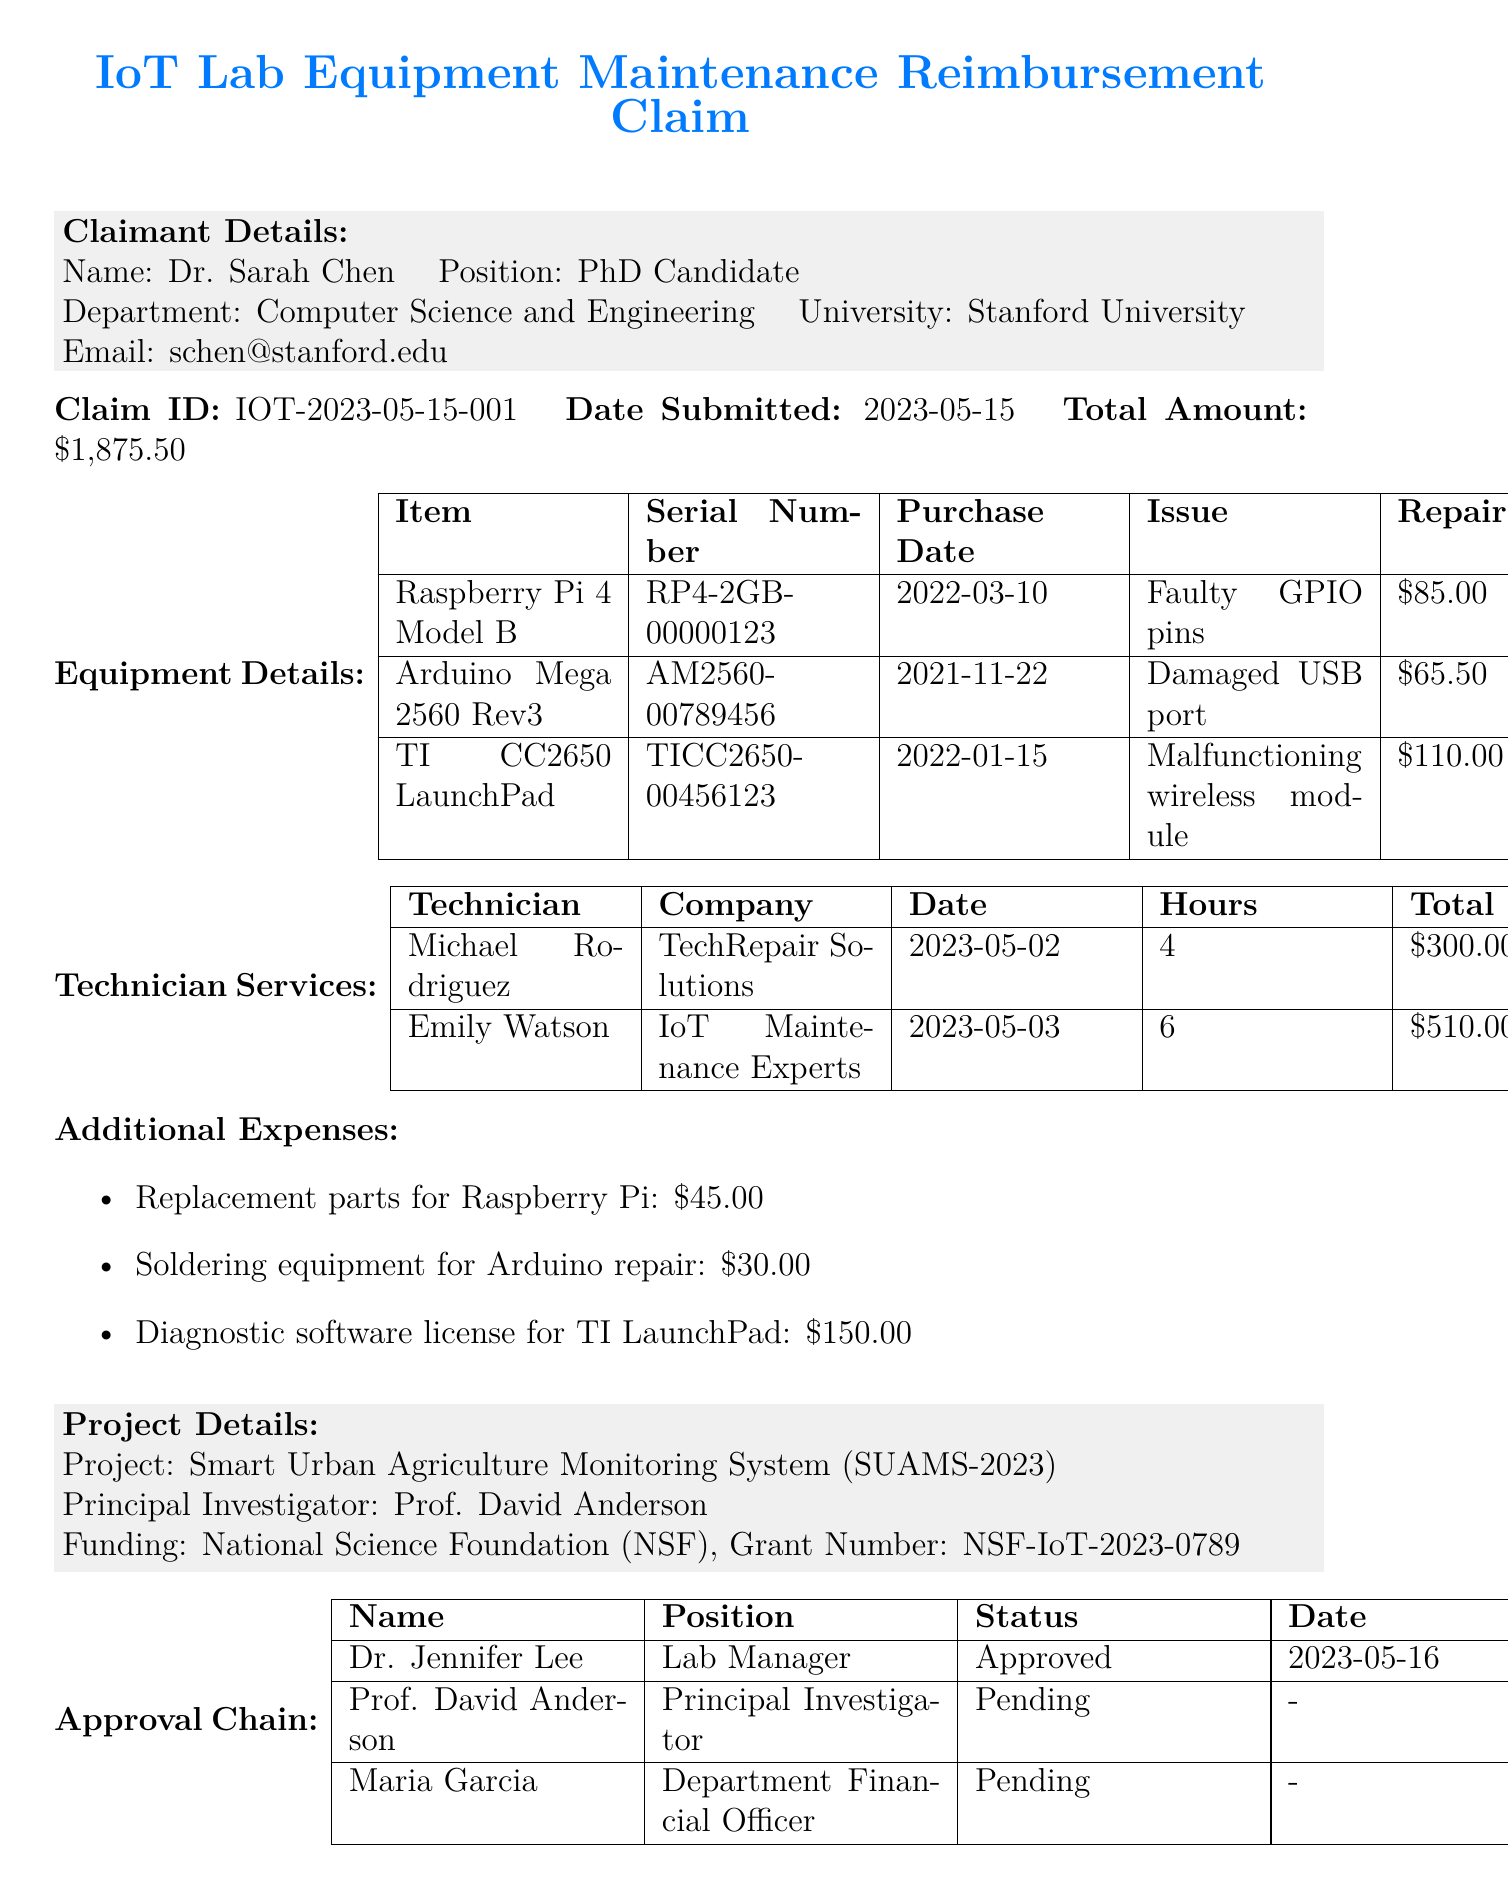what is the name of the claimant? The name of the claimant is specified in the document under Claimant Details.
Answer: Dr. Sarah Chen what is the total amount claimed? The total amount claimed is indicated in the Claim Details section of the document.
Answer: $1,875.50 what is the repair cost for the Arduino Mega 2560? The repair cost is listed in the Equipment Details section.
Answer: $65.50 who is the principal investigator of the project? The principal investigator's name is mentioned in the Project Details section.
Answer: Prof. David Anderson how many hours did Emily Watson work? The number of hours worked by Emily Watson is provided in the Technician Services section.
Answer: 6 what issue did the Raspberry Pi 4 Model B have? The issue is listed alongside the equipment details in the document.
Answer: Faulty GPIO pins what is the date of submission for the claim? The date of submission is mentioned in the Claim Details section.
Answer: 2023-05-15 how much did the technician services cost in total? The total fee for technician services is summarized in the Technician Services section.
Answer: $810.00 what is the status of Prof. David Anderson's approval? The approval status is listed in the Approval Chain section.
Answer: Pending 